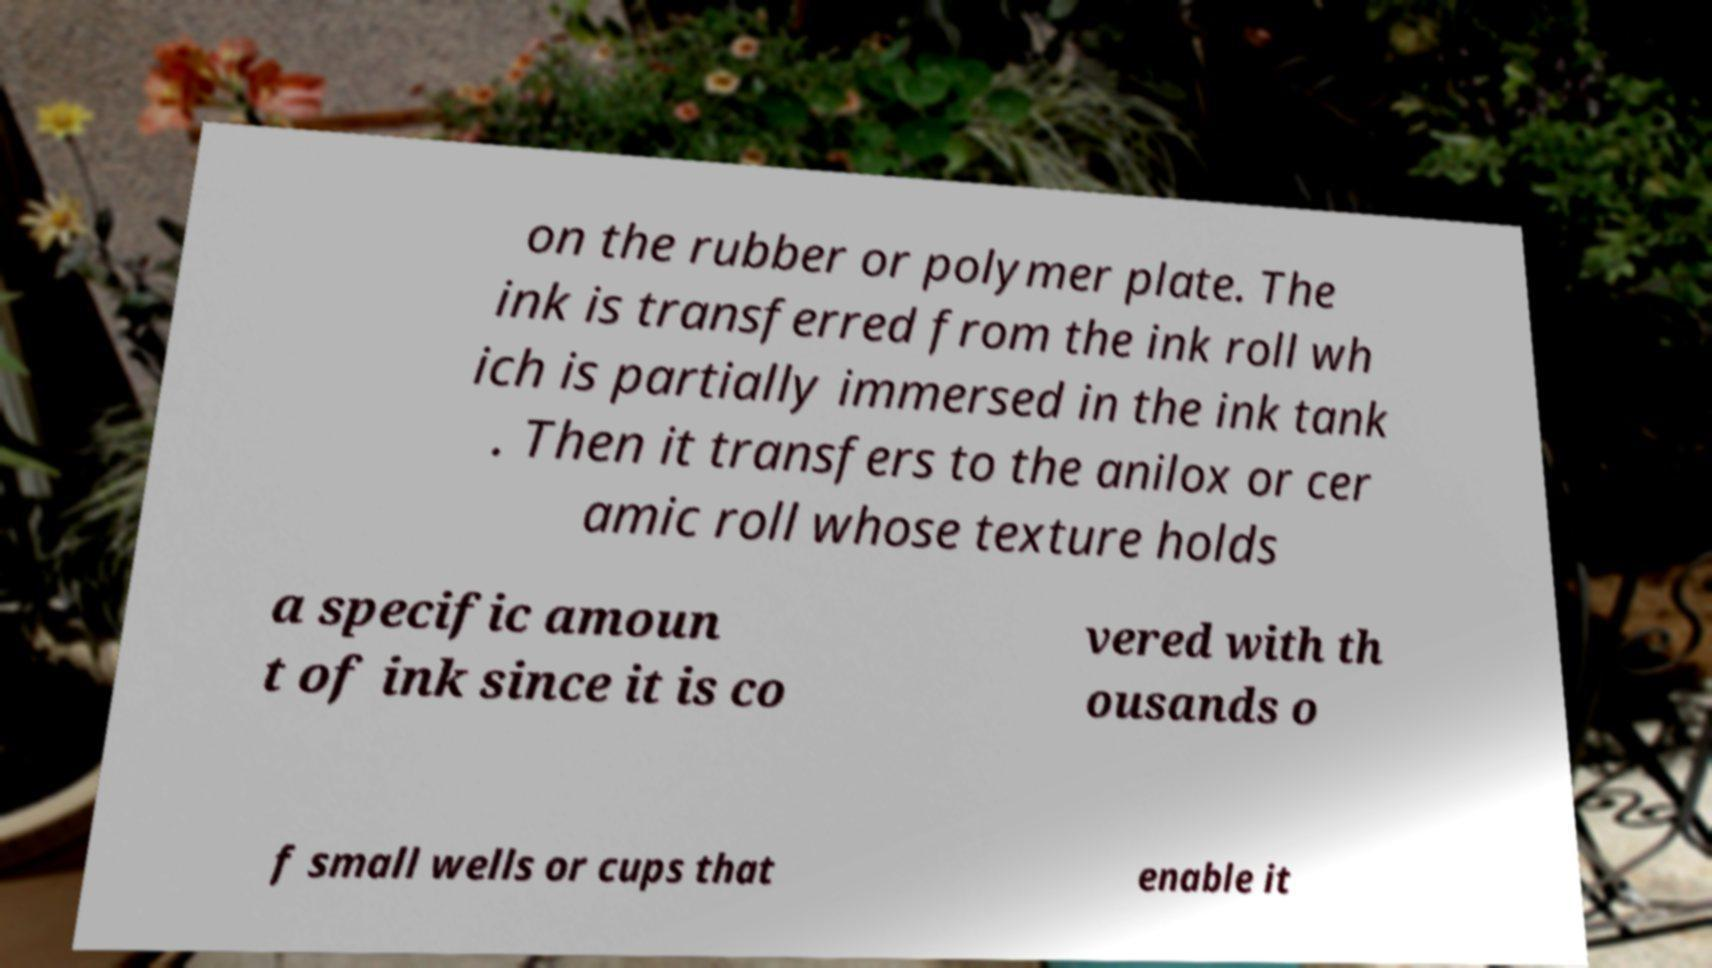What messages or text are displayed in this image? I need them in a readable, typed format. on the rubber or polymer plate. The ink is transferred from the ink roll wh ich is partially immersed in the ink tank . Then it transfers to the anilox or cer amic roll whose texture holds a specific amoun t of ink since it is co vered with th ousands o f small wells or cups that enable it 